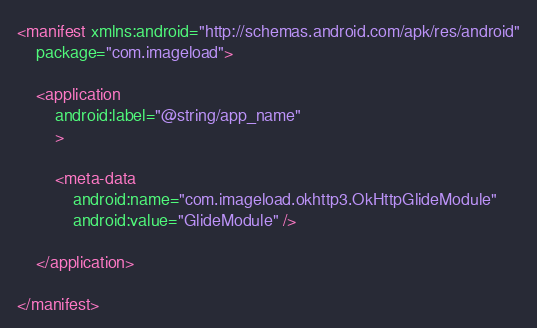Convert code to text. <code><loc_0><loc_0><loc_500><loc_500><_XML_><manifest xmlns:android="http://schemas.android.com/apk/res/android"
    package="com.imageload">

    <application
        android:label="@string/app_name"
        >

        <meta-data
            android:name="com.imageload.okhttp3.OkHttpGlideModule"
            android:value="GlideModule" />

    </application>

</manifest>
</code> 